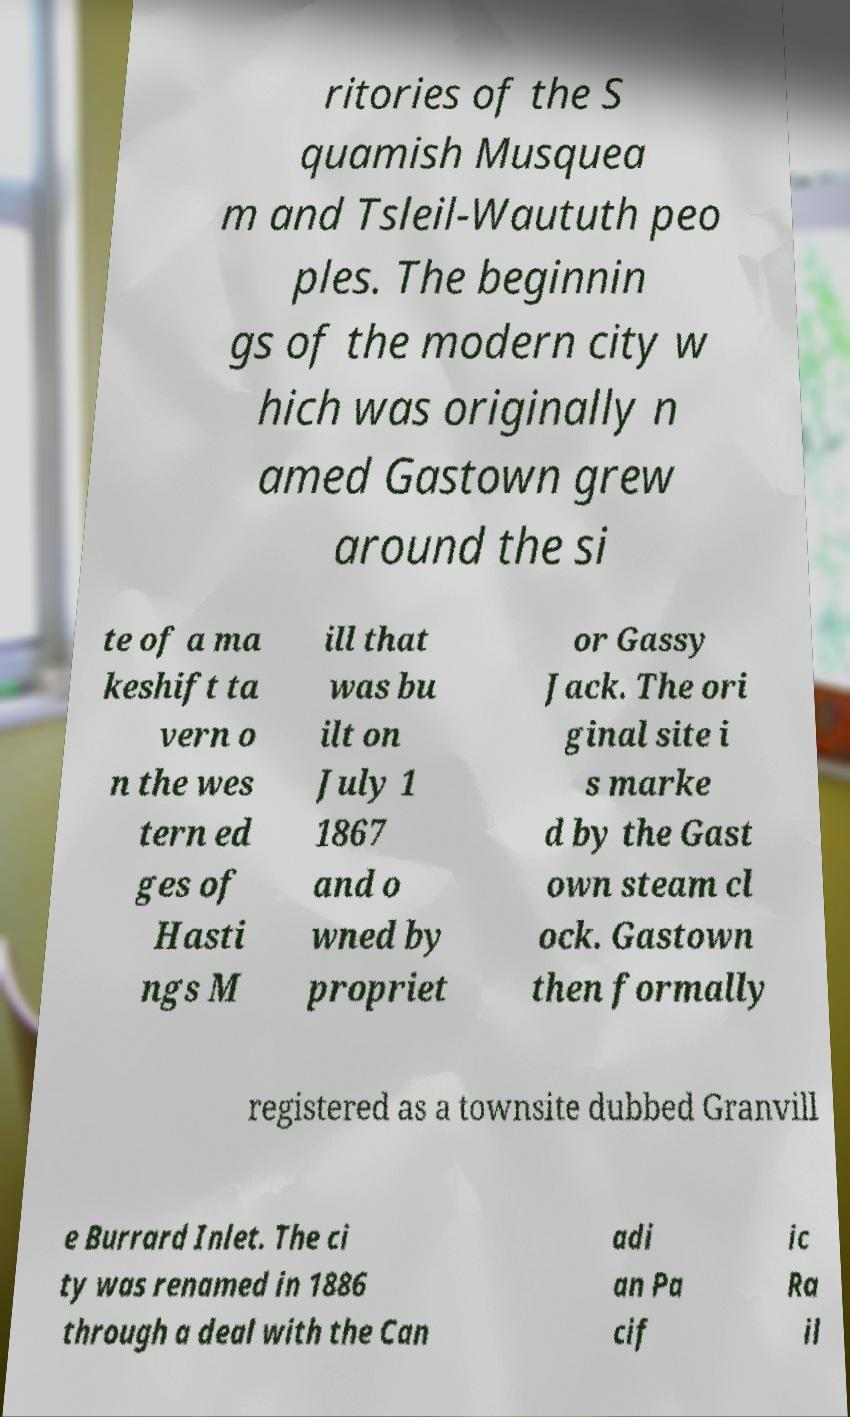What messages or text are displayed in this image? I need them in a readable, typed format. ritories of the S quamish Musquea m and Tsleil-Waututh peo ples. The beginnin gs of the modern city w hich was originally n amed Gastown grew around the si te of a ma keshift ta vern o n the wes tern ed ges of Hasti ngs M ill that was bu ilt on July 1 1867 and o wned by propriet or Gassy Jack. The ori ginal site i s marke d by the Gast own steam cl ock. Gastown then formally registered as a townsite dubbed Granvill e Burrard Inlet. The ci ty was renamed in 1886 through a deal with the Can adi an Pa cif ic Ra il 